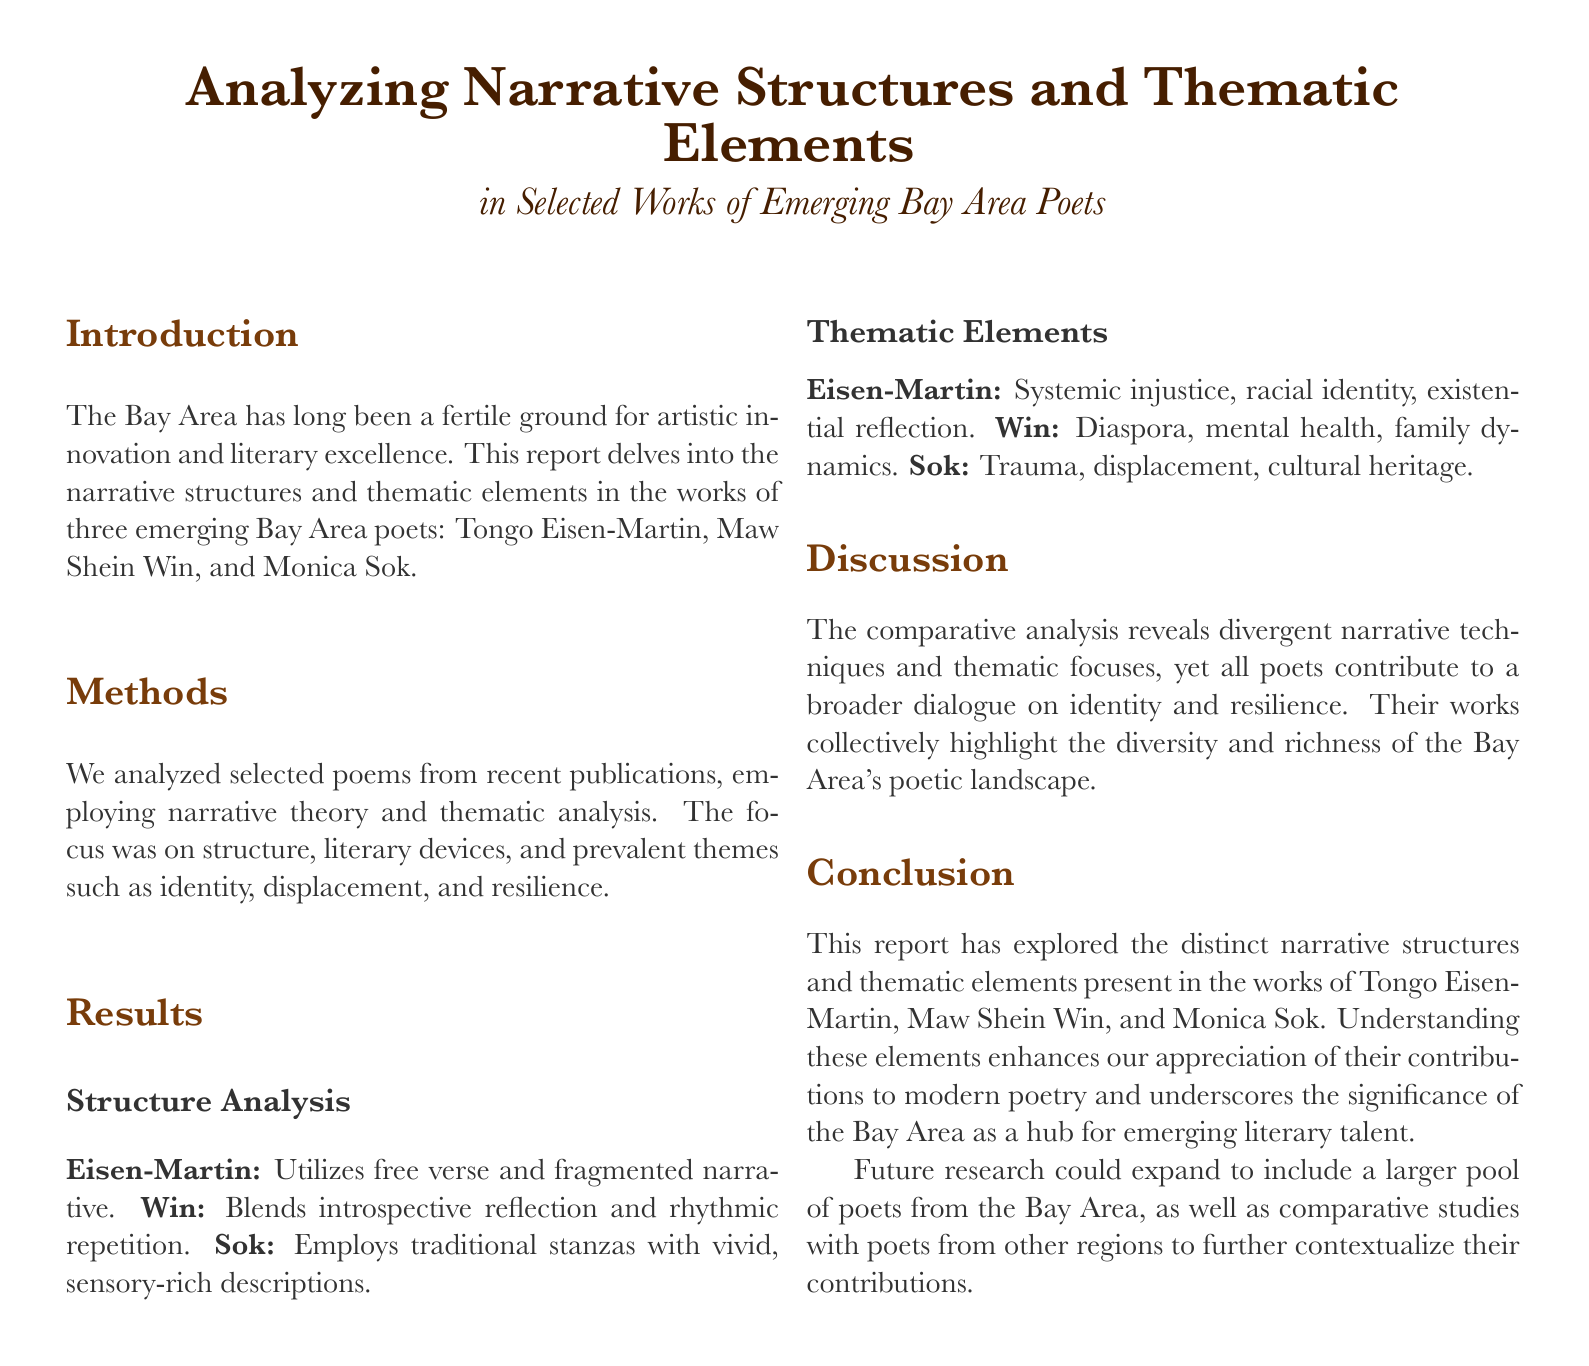What is the main focus of the report? The report delves into narrative structures and thematic elements in the works of three emerging Bay Area poets.
Answer: Narrative structures and thematic elements Who are the three poets analyzed in the report? The document mentions three poets: Tongo Eisen-Martin, Maw Shein Win, and Monica Sok.
Answer: Tongo Eisen-Martin, Maw Shein Win, and Monica Sok What literary technique does Eisen-Martin primarily use? The report states that Eisen-Martin utilizes free verse and fragmented narrative.
Answer: Free verse and fragmented narrative What theme is prevalent in Maw Shein Win's poetry? The report identifies diaspora, mental health, and family dynamics as themes in Win's work.
Answer: Diaspora What is the conclusion drawn about the poets' works? The conclusion suggests that the poets contribute to a broader dialogue on identity and resilience.
Answer: Broader dialogue on identity and resilience What could future research expand to include? The report notes that future research could include a larger pool of poets from the Bay Area and comparative studies with poets from other regions.
Answer: A larger pool of poets and comparative studies Which poet employs traditional stanzas? The document specifies that Monica Sok employs traditional stanzas with vivid descriptions.
Answer: Monica Sok Which theme is associated with Tongo Eisen-Martin? The document lists systemic injustice, racial identity, and existential reflection as themes in Eisen-Martin's work.
Answer: Systemic injustice 